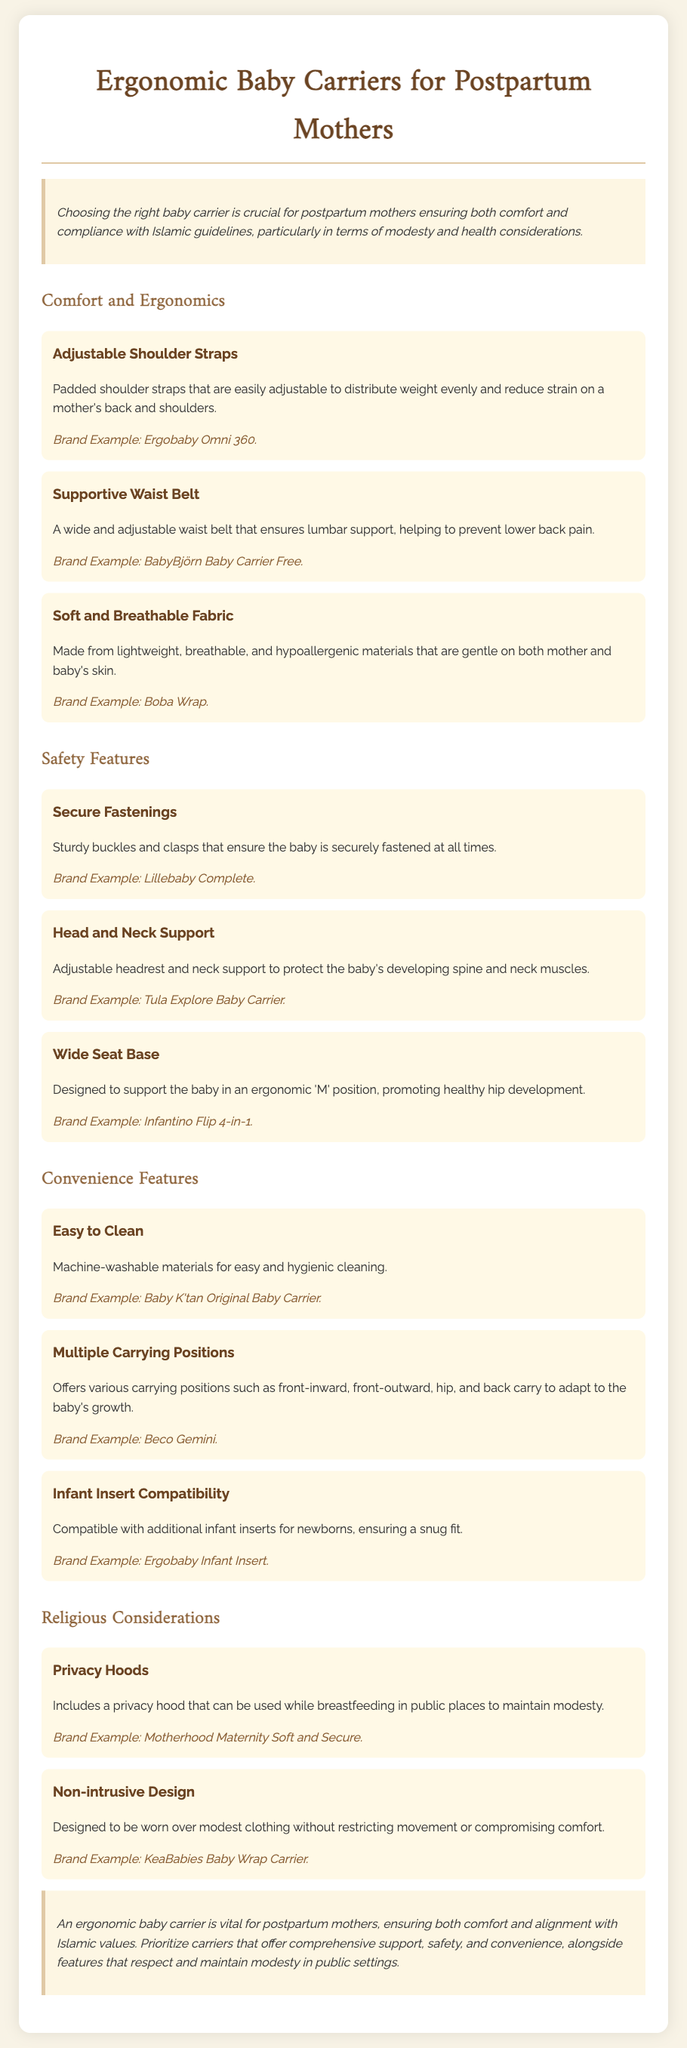What is the title of the document? The title of the document is presented in the main heading.
Answer: Ergonomic Baby Carriers for Postpartum Mothers What is one feature that enhances comfort for postpartum mothers? The document specifies various features that enhance comfort, such as adjustable shoulder straps.
Answer: Adjustable Shoulder Straps What is the brand example for the supportive waist belt? The document provides specific brands that exemplify different features.
Answer: BabyBjörn Baby Carrier Free What is the purpose of the privacy hood? The privacy hood's purpose is mentioned in the context of maintaining modesty while breastfeeding.
Answer: Maintain modesty How many carrying positions does the document mention? The document explicitly lists the different carrying positions available for the carriers.
Answer: Various carrying positions Which material type is highlighted for its benefits in the document? The document specifies materials that are soft, breathable, and hypoallergenic, which are beneficial for mother and baby.
Answer: Soft and Breathable Fabric What is the significance of the non-intrusive design? The non-intrusive design is designed to align with the wearer’s modest clothing without restricting movement.
Answer: Modest clothing Which feature protects the baby's developing spine and neck muscles? The document lists specific features that provide necessary support to the baby.
Answer: Head and Neck Support How many convenience features are detailed in the document? The number of convenience features outlined helps to determine the document's focus on practicality.
Answer: Three features 